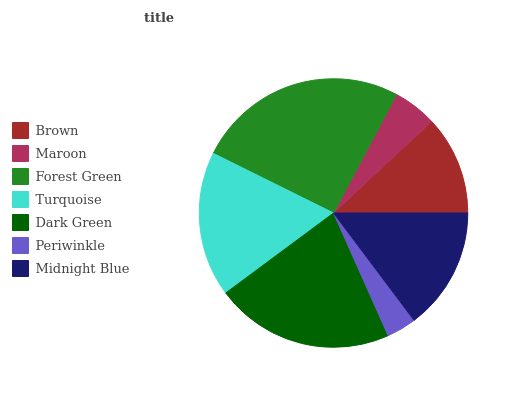Is Periwinkle the minimum?
Answer yes or no. Yes. Is Forest Green the maximum?
Answer yes or no. Yes. Is Maroon the minimum?
Answer yes or no. No. Is Maroon the maximum?
Answer yes or no. No. Is Brown greater than Maroon?
Answer yes or no. Yes. Is Maroon less than Brown?
Answer yes or no. Yes. Is Maroon greater than Brown?
Answer yes or no. No. Is Brown less than Maroon?
Answer yes or no. No. Is Midnight Blue the high median?
Answer yes or no. Yes. Is Midnight Blue the low median?
Answer yes or no. Yes. Is Periwinkle the high median?
Answer yes or no. No. Is Turquoise the low median?
Answer yes or no. No. 